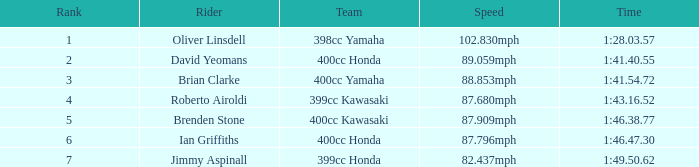What is the time of the rider ranked 6? 1:46.47.30. 